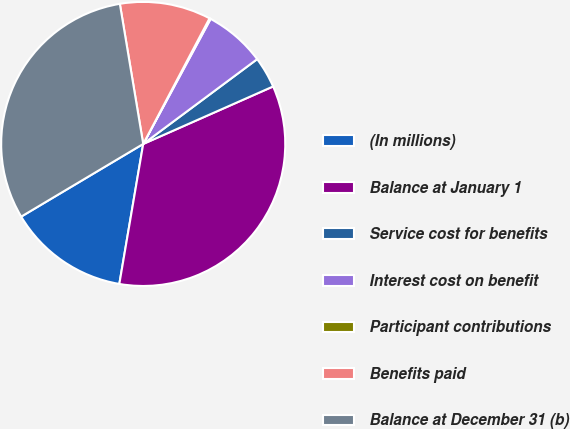Convert chart to OTSL. <chart><loc_0><loc_0><loc_500><loc_500><pie_chart><fcel>(In millions)<fcel>Balance at January 1<fcel>Service cost for benefits<fcel>Interest cost on benefit<fcel>Participant contributions<fcel>Benefits paid<fcel>Balance at December 31 (b)<nl><fcel>13.76%<fcel>34.32%<fcel>3.55%<fcel>6.95%<fcel>0.14%<fcel>10.36%<fcel>30.92%<nl></chart> 